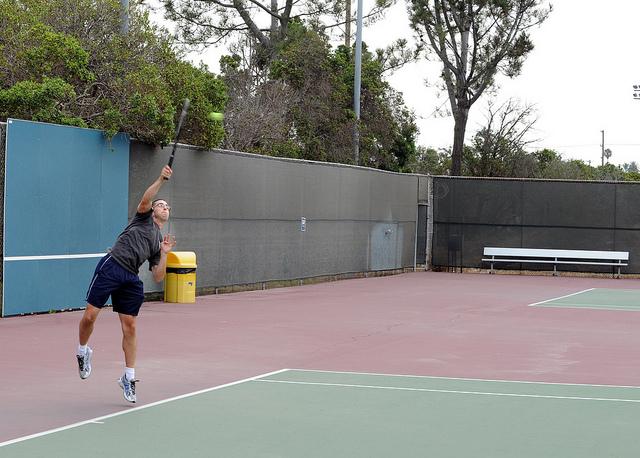Does this man know how to play tennis?
Give a very brief answer. Yes. What is the guy trying to do?
Concise answer only. Hit ball. What sport is this?
Answer briefly. Tennis. 